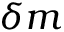Convert formula to latex. <formula><loc_0><loc_0><loc_500><loc_500>\delta m</formula> 